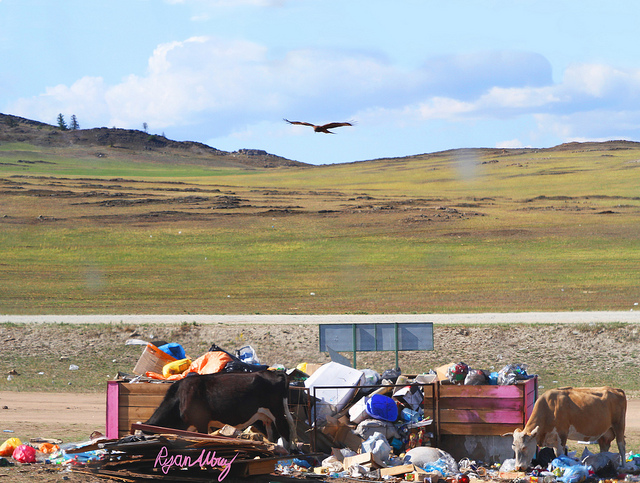Identify the text contained in this image. Ryan Way 